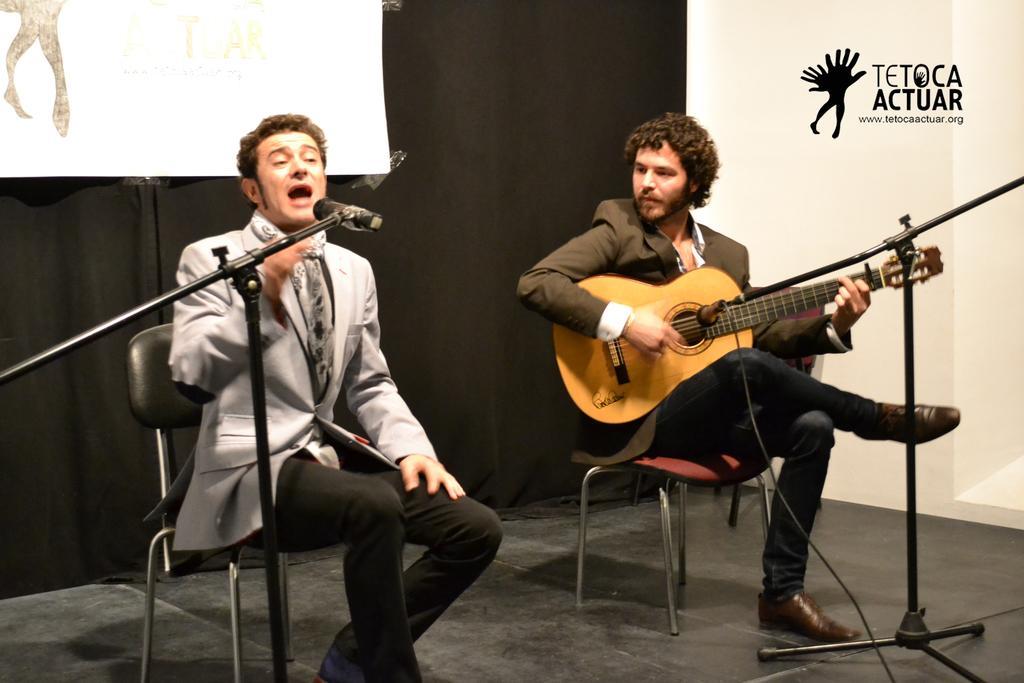Please provide a concise description of this image. In this image there are two persons. The person with at the right side of the image is sitting and playing guitar. The person in the left side of the image is sitting and singing. At the back there is a black curtain and poster and in the front there are microphones. 